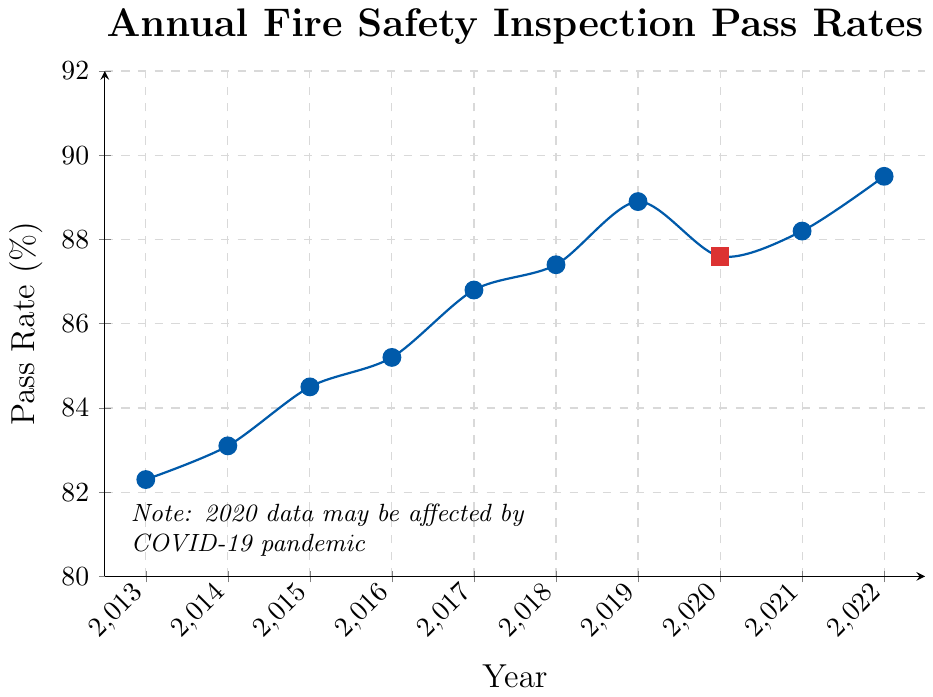What is the pass rate in 2017? The y-axis of the line chart represents the pass rate percentages. Locate the data point at the year 2017 on the x-axis, then follow it up to the corresponding y-axis value.
Answer: 86.8% Which year had the highest pass rate? Identify the highest point on the line chart and check the corresponding year on the x-axis.
Answer: 2022 What trend do you observe in the pass rates over the decade? To identify the trend, observe the overall direction of the line from 2013 to 2022. The line generally moves upward, showing an increasing trend in pass rates, although with a slight dip in 2020.
Answer: Increasing What is the difference in pass rate between 2015 and 2020? Locate the pass rates for 2015 and 2020, then subtract the 2015 pass rate from the 2020 pass rate.
Answer: 87.6% - 84.5% = 3.1% What is the average pass rate from 2013 to 2017 inclusive? Sum the pass rates from 2013 to 2017, then divide by the number of years. (82.3 + 83.1 + 84.5 + 85.2 + 86.8) / 5 = 84.38%
Answer: 84.38% In which year was the pass rate approximately the same before and after a noticeable dip? Identify the year with a noticeable dip (2020), then find the adjacent years (2019 and 2021). Compare their pass rates.
Answer: 2019 and 2021 How much did the pass rate change from 2019 to 2020? Locate the pass rates for both years and subtract 2020's pass rate from 2019's pass rate.
Answer: 88.9% - 87.6% = 1.3% Which years have a pass rate above 88%? Identify all data points on the chart where the y-axis value is above 88%.
Answer: 2019, 2021, 2022 Describe the color used for data points in 2020, and why might it be different? The 2020 data point is marked in red, while other years are in blue. The note mentions that 2020 data might be affected by the COVID-19 pandemic, possibly explaining the color difference.
Answer: Red Calculate the percentage increase in pass rate from 2013 to 2022. Use the formula for percentage increase: [(Final Value - Initial Value) / Initial Value] * 100. For pass rates: [(89.5 - 82.3) / 82.3] * 100
Answer: 8.7% 